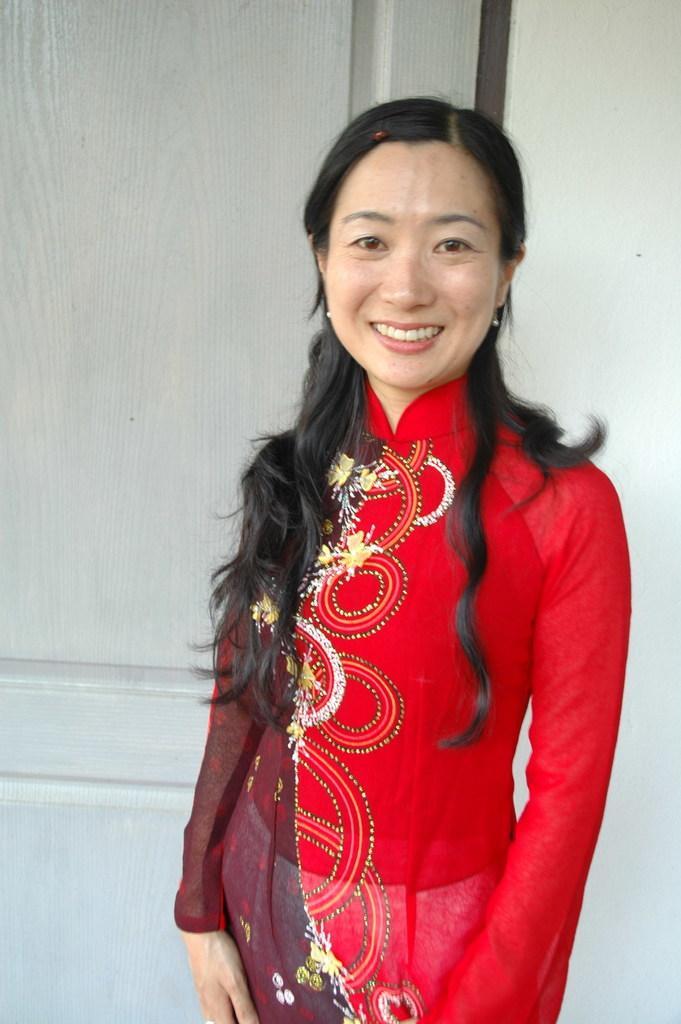Please provide a concise description of this image. In the background we can see the wall and we can see the partial part of a door. In this picture we can see a woman standing and she is smiling. 